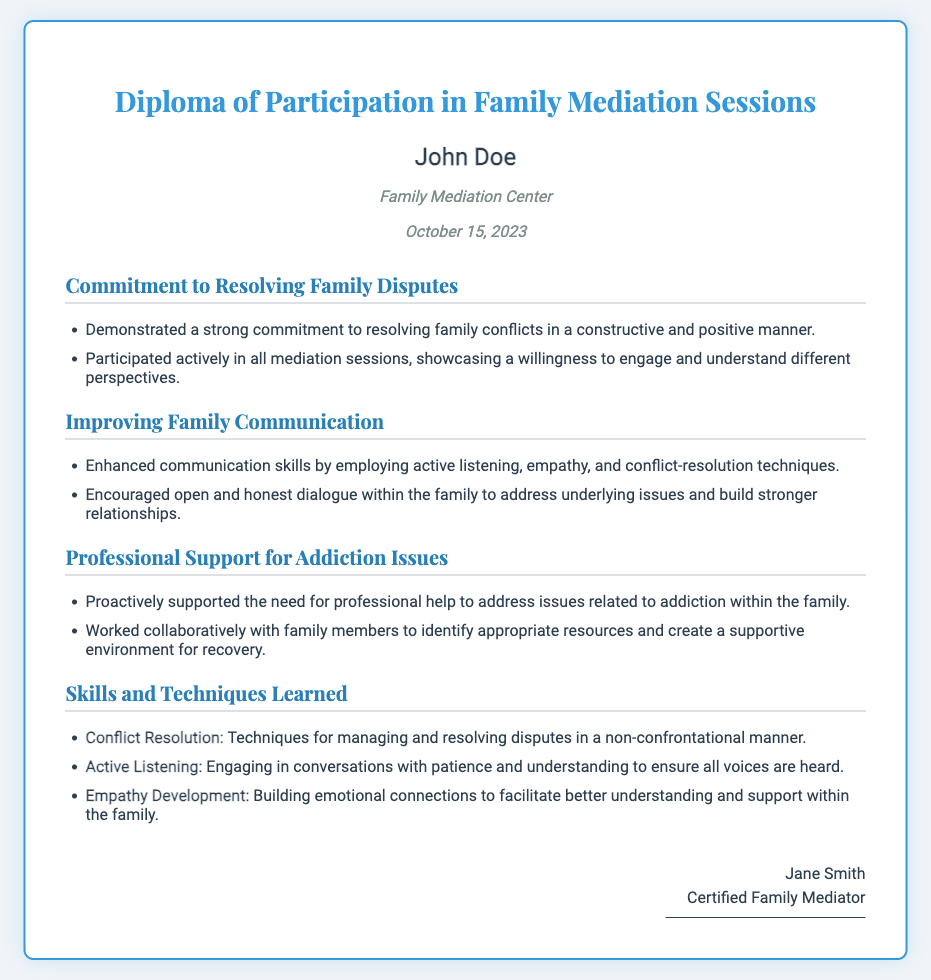What is the title of the document? The title is indicated at the top of the document, reflecting its main subject.
Answer: Diploma of Participation in Family Mediation Sessions Who is the participant named in the diploma? The participant's name is prominently displayed under the title.
Answer: John Doe What is the issuing organization? The organization that issued the diploma is stated clearly in the document.
Answer: Family Mediation Center On what date was the diploma issued? The date of issuance is provided in a specific format in the document.
Answer: October 15, 2023 What commitment does the diploma highlight regarding family disputes? The document outlines the participant's engagement in mediation for family disputes.
Answer: Resolving family conflicts What skills were developed as per the document? The document lists several important skills learned during the mediation sessions.
Answer: Conflict Resolution What technique is emphasized for improving family communication? A technique for enhancing communication is mentioned multiple times in the document.
Answer: Active Listening What proactive support is mentioned in relation to addiction issues? The document specifies the participant's efforts concerning addiction within their family.
Answer: Professional help Who is the certified mediator that signed the document? The mediator’s name is shown at the bottom of the diploma, indicating their authority.
Answer: Jane Smith 